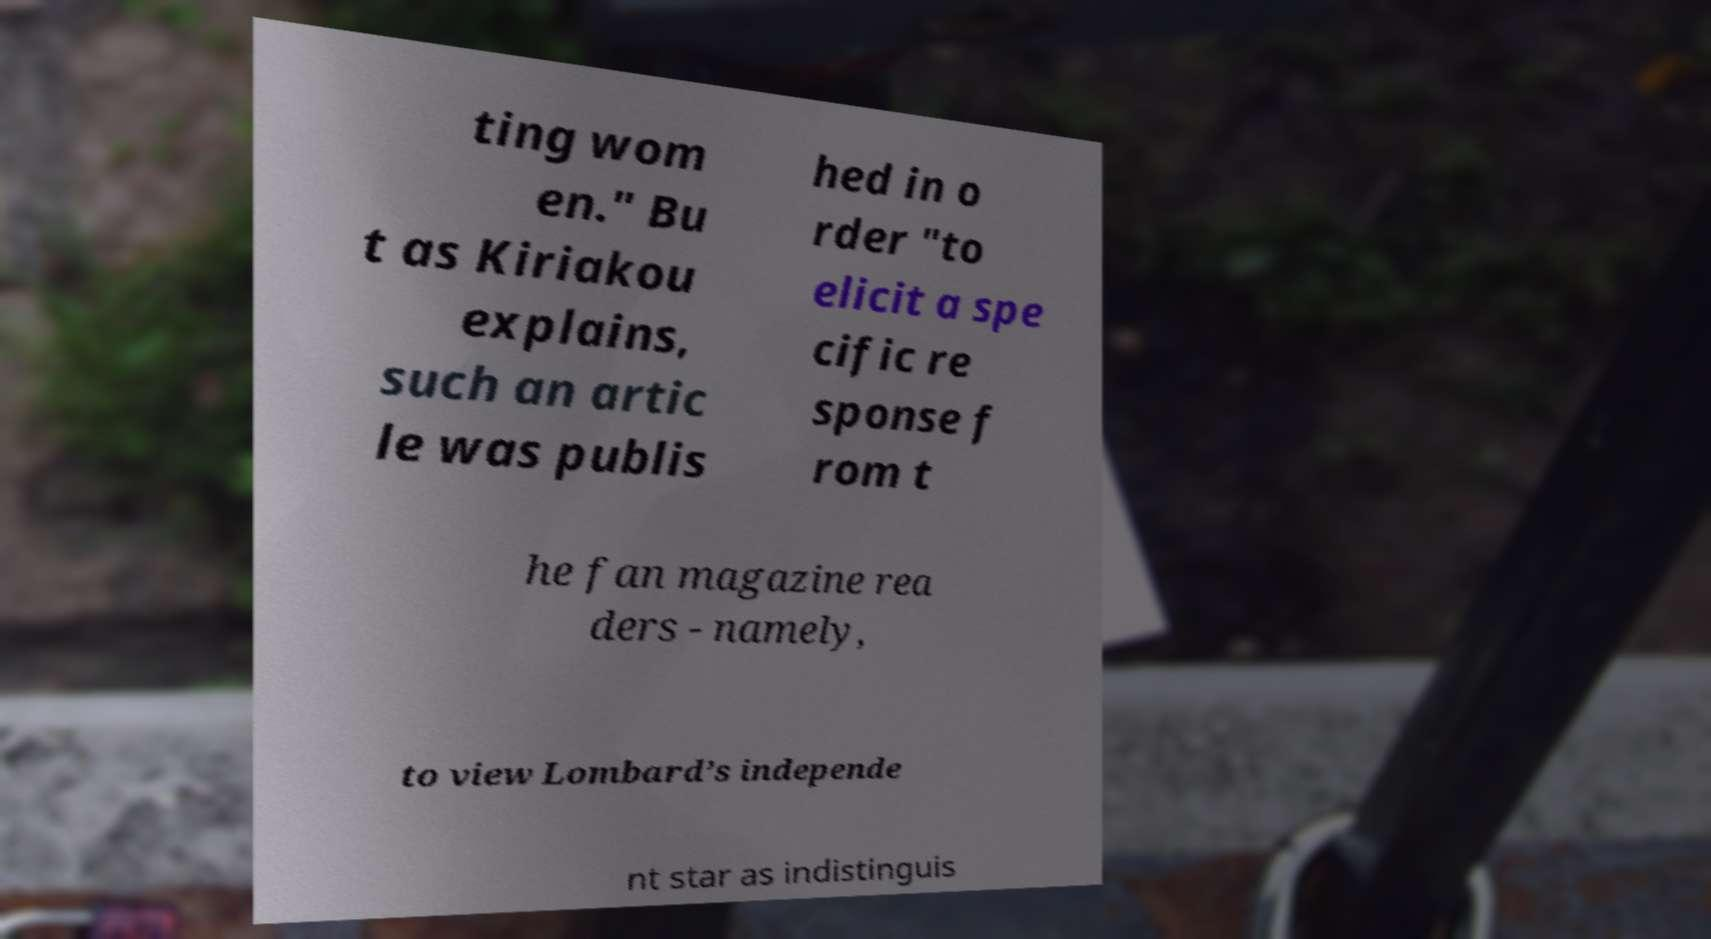Can you read and provide the text displayed in the image?This photo seems to have some interesting text. Can you extract and type it out for me? ting wom en." Bu t as Kiriakou explains, such an artic le was publis hed in o rder "to elicit a spe cific re sponse f rom t he fan magazine rea ders - namely, to view Lombard’s independe nt star as indistinguis 